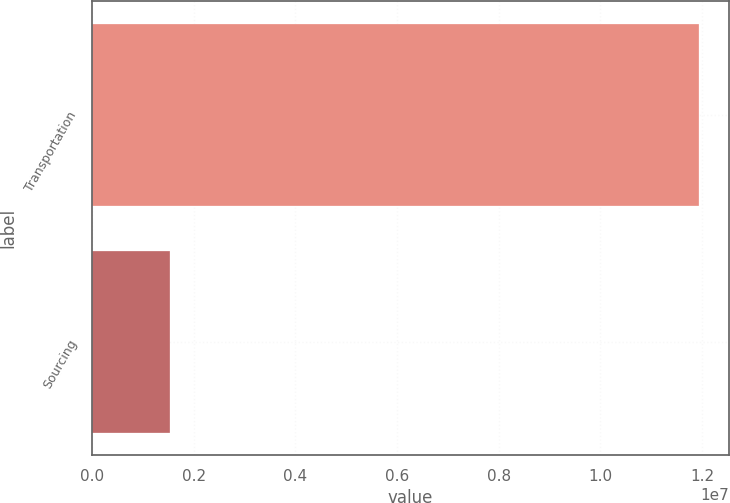Convert chart. <chart><loc_0><loc_0><loc_500><loc_500><bar_chart><fcel>Transportation<fcel>Sourcing<nl><fcel>1.19365e+07<fcel>1.53356e+06<nl></chart> 